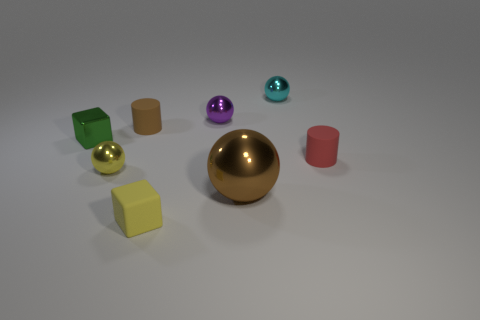There is a cylinder left of the tiny thing in front of the brown metallic ball; how many large brown balls are to the left of it?
Keep it short and to the point. 0. What is the material of the ball that is behind the yellow ball and in front of the small cyan thing?
Your answer should be very brief. Metal. Are the tiny cyan ball and the small sphere to the left of the small brown rubber thing made of the same material?
Make the answer very short. Yes. Are there more small rubber things that are on the left side of the cyan shiny sphere than red matte objects in front of the red rubber object?
Your answer should be compact. Yes. There is a small yellow shiny thing; what shape is it?
Provide a succinct answer. Sphere. Are the yellow thing behind the yellow block and the block left of the small yellow cube made of the same material?
Make the answer very short. Yes. There is a small object that is in front of the small yellow ball; what is its shape?
Provide a short and direct response. Cube. The brown rubber object that is the same shape as the red thing is what size?
Provide a succinct answer. Small. Does the small shiny cube have the same color as the big object?
Your answer should be very brief. No. Is there anything else that is the same shape as the big shiny object?
Ensure brevity in your answer.  Yes. 